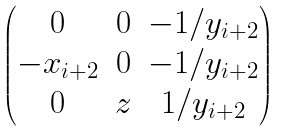Convert formula to latex. <formula><loc_0><loc_0><loc_500><loc_500>\begin{pmatrix} 0 & 0 & - 1 / y _ { i + 2 } \\ - x _ { i + 2 } & 0 & - 1 / y _ { i + 2 } \\ 0 & z & 1 / y _ { i + 2 } \end{pmatrix}</formula> 